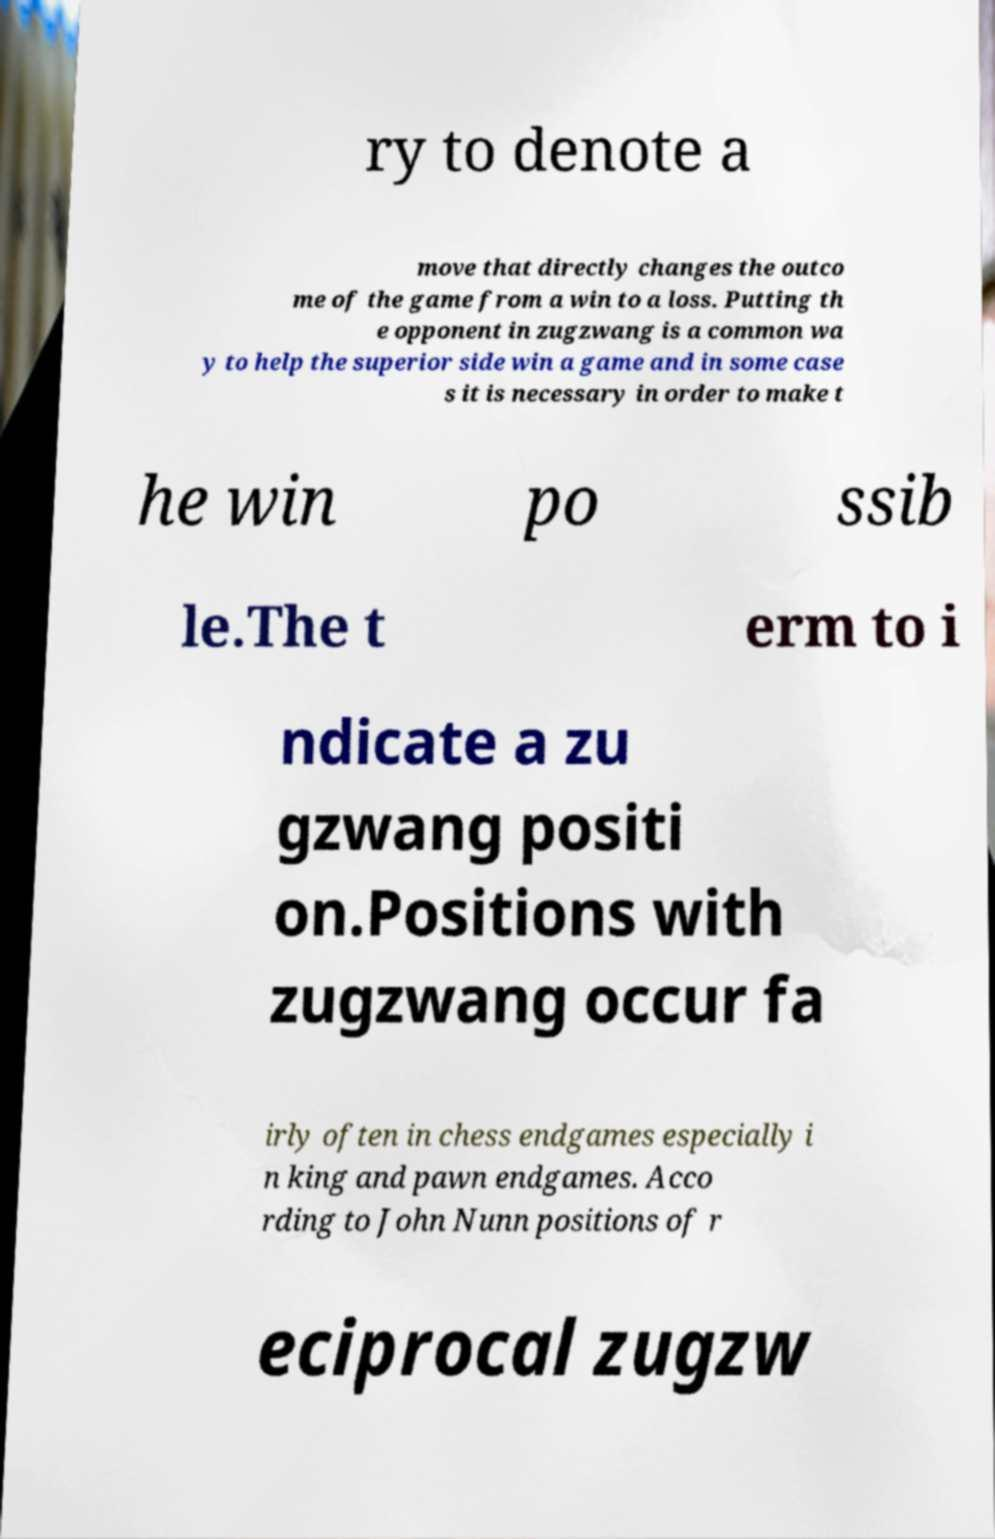What messages or text are displayed in this image? I need them in a readable, typed format. ry to denote a move that directly changes the outco me of the game from a win to a loss. Putting th e opponent in zugzwang is a common wa y to help the superior side win a game and in some case s it is necessary in order to make t he win po ssib le.The t erm to i ndicate a zu gzwang positi on.Positions with zugzwang occur fa irly often in chess endgames especially i n king and pawn endgames. Acco rding to John Nunn positions of r eciprocal zugzw 